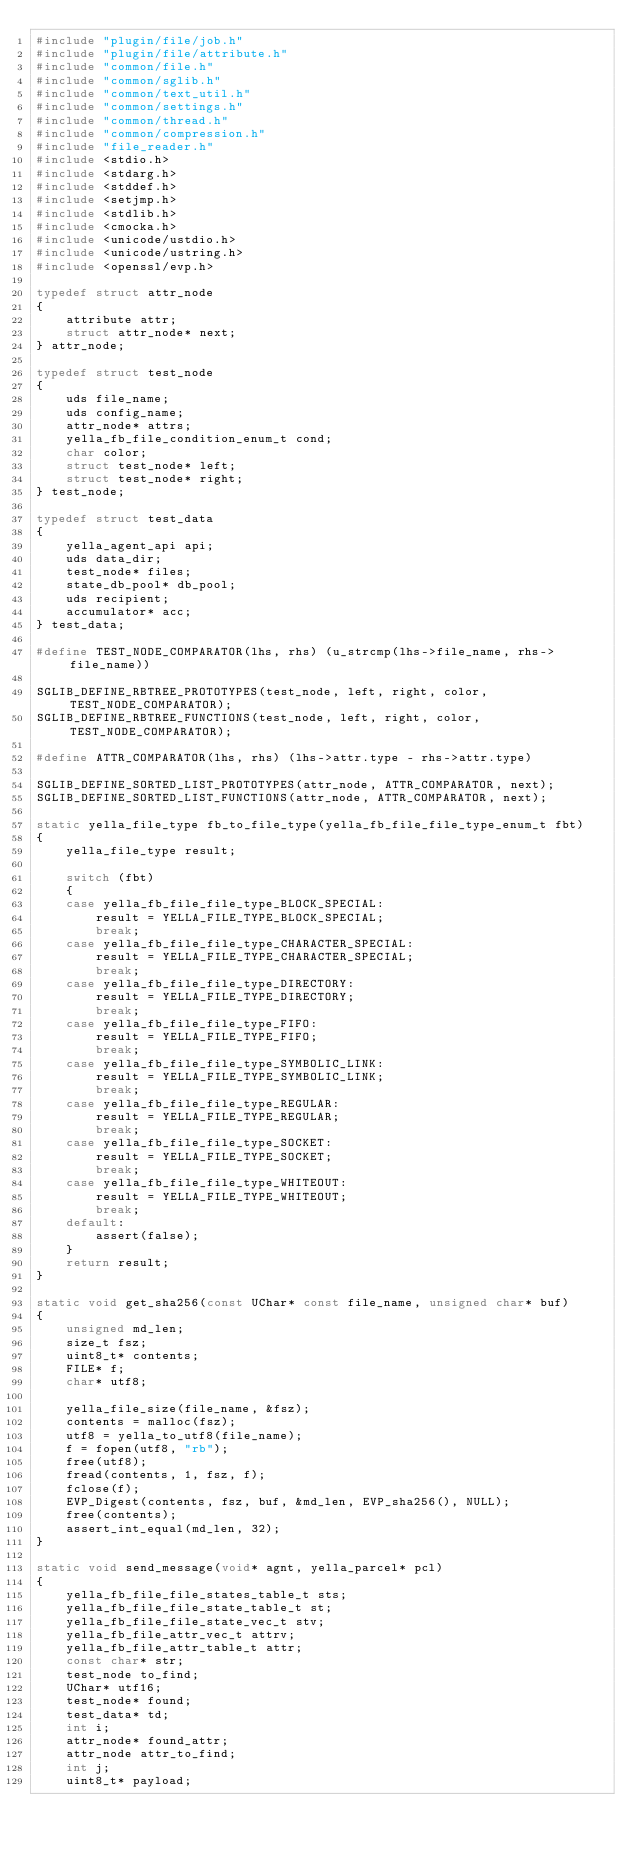Convert code to text. <code><loc_0><loc_0><loc_500><loc_500><_C_>#include "plugin/file/job.h"
#include "plugin/file/attribute.h"
#include "common/file.h"
#include "common/sglib.h"
#include "common/text_util.h"
#include "common/settings.h"
#include "common/thread.h"
#include "common/compression.h"
#include "file_reader.h"
#include <stdio.h>
#include <stdarg.h>
#include <stddef.h>
#include <setjmp.h>
#include <stdlib.h>
#include <cmocka.h>
#include <unicode/ustdio.h>
#include <unicode/ustring.h>
#include <openssl/evp.h>

typedef struct attr_node
{
    attribute attr;
    struct attr_node* next;
} attr_node;

typedef struct test_node
{
    uds file_name;
    uds config_name;
    attr_node* attrs;
    yella_fb_file_condition_enum_t cond;
    char color;
    struct test_node* left;
    struct test_node* right;
} test_node;

typedef struct test_data
{
    yella_agent_api api;
    uds data_dir;
    test_node* files;
    state_db_pool* db_pool;
    uds recipient;
    accumulator* acc;
} test_data;

#define TEST_NODE_COMPARATOR(lhs, rhs) (u_strcmp(lhs->file_name, rhs->file_name))

SGLIB_DEFINE_RBTREE_PROTOTYPES(test_node, left, right, color, TEST_NODE_COMPARATOR);
SGLIB_DEFINE_RBTREE_FUNCTIONS(test_node, left, right, color, TEST_NODE_COMPARATOR);

#define ATTR_COMPARATOR(lhs, rhs) (lhs->attr.type - rhs->attr.type)

SGLIB_DEFINE_SORTED_LIST_PROTOTYPES(attr_node, ATTR_COMPARATOR, next);
SGLIB_DEFINE_SORTED_LIST_FUNCTIONS(attr_node, ATTR_COMPARATOR, next);

static yella_file_type fb_to_file_type(yella_fb_file_file_type_enum_t fbt)
{
    yella_file_type result;

    switch (fbt)
    {
    case yella_fb_file_file_type_BLOCK_SPECIAL:
        result = YELLA_FILE_TYPE_BLOCK_SPECIAL;
        break;
    case yella_fb_file_file_type_CHARACTER_SPECIAL:
        result = YELLA_FILE_TYPE_CHARACTER_SPECIAL;
        break;
    case yella_fb_file_file_type_DIRECTORY:
        result = YELLA_FILE_TYPE_DIRECTORY;
        break;
    case yella_fb_file_file_type_FIFO:
        result = YELLA_FILE_TYPE_FIFO;
        break;
    case yella_fb_file_file_type_SYMBOLIC_LINK:
        result = YELLA_FILE_TYPE_SYMBOLIC_LINK;
        break;
    case yella_fb_file_file_type_REGULAR:
        result = YELLA_FILE_TYPE_REGULAR;
        break;
    case yella_fb_file_file_type_SOCKET:
        result = YELLA_FILE_TYPE_SOCKET;
        break;
    case yella_fb_file_file_type_WHITEOUT:
        result = YELLA_FILE_TYPE_WHITEOUT;
        break;
    default:
        assert(false);
    }
    return result;
}

static void get_sha256(const UChar* const file_name, unsigned char* buf)
{
    unsigned md_len;
    size_t fsz;
    uint8_t* contents;
    FILE* f;
    char* utf8;

    yella_file_size(file_name, &fsz);
    contents = malloc(fsz);
    utf8 = yella_to_utf8(file_name);
    f = fopen(utf8, "rb");
    free(utf8);
    fread(contents, 1, fsz, f);
    fclose(f);
    EVP_Digest(contents, fsz, buf, &md_len, EVP_sha256(), NULL);
    free(contents);
    assert_int_equal(md_len, 32);
}

static void send_message(void* agnt, yella_parcel* pcl)
{
    yella_fb_file_file_states_table_t sts;
    yella_fb_file_file_state_table_t st;
    yella_fb_file_file_state_vec_t stv;
    yella_fb_file_attr_vec_t attrv;
    yella_fb_file_attr_table_t attr;
    const char* str;
    test_node to_find;
    UChar* utf16;
    test_node* found;
    test_data* td;
    int i;
    attr_node* found_attr;
    attr_node attr_to_find;
    int j;
    uint8_t* payload;</code> 